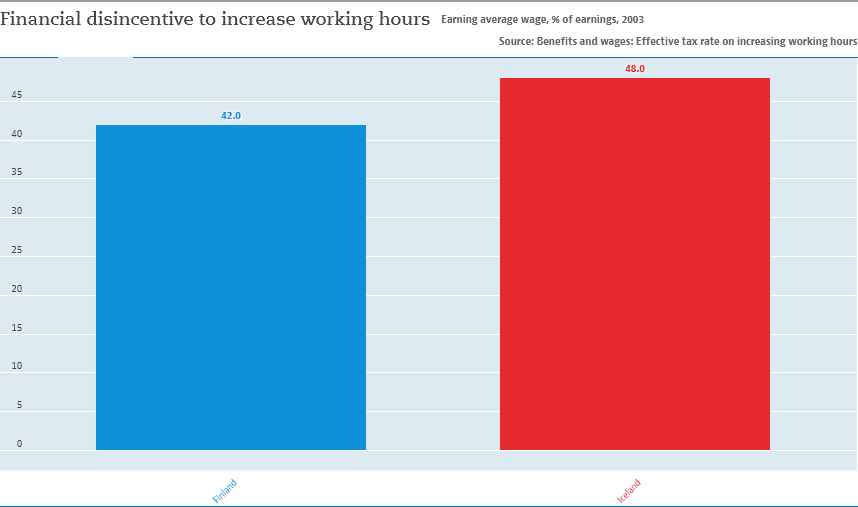Give some essential details in this illustration. The difference between two bars is six. The color of the longest bar is red. 